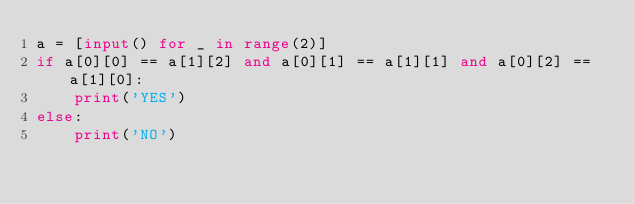<code> <loc_0><loc_0><loc_500><loc_500><_Python_>a = [input() for _ in range(2)]
if a[0][0] == a[1][2] and a[0][1] == a[1][1] and a[0][2] == a[1][0]:
    print('YES')
else:
    print('NO')</code> 